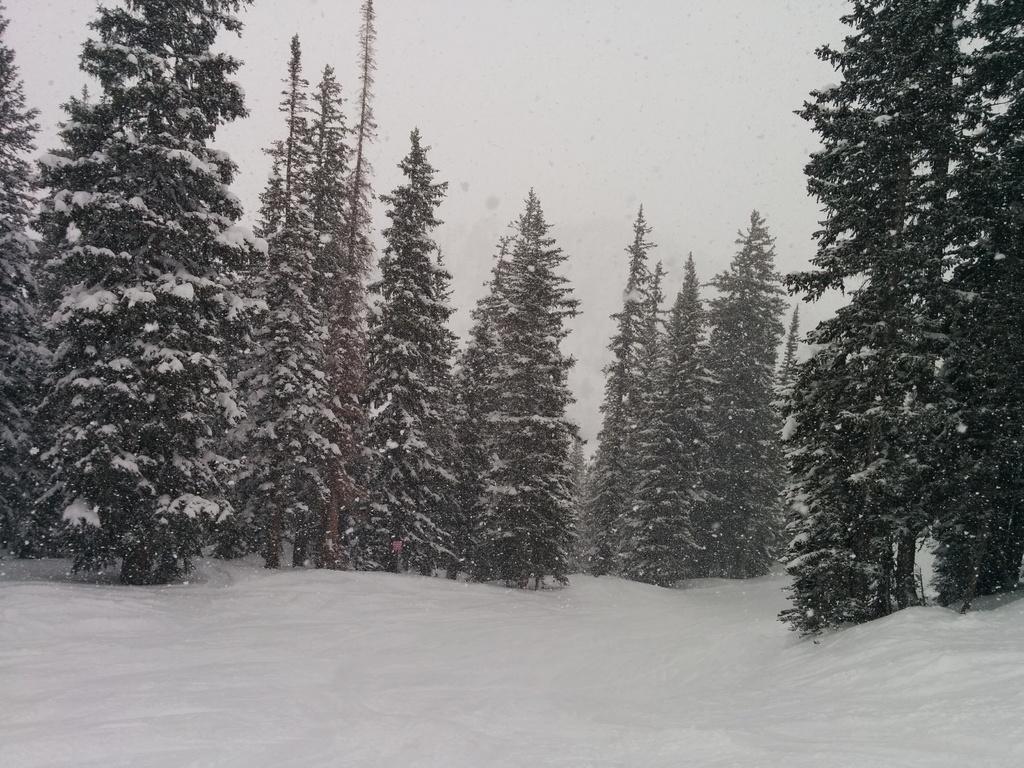Can you describe this image briefly? This picture is clicked outside the city. In the foreground we can see there is a lot of snow. In the center there are some trees. In the background there is a sky. 